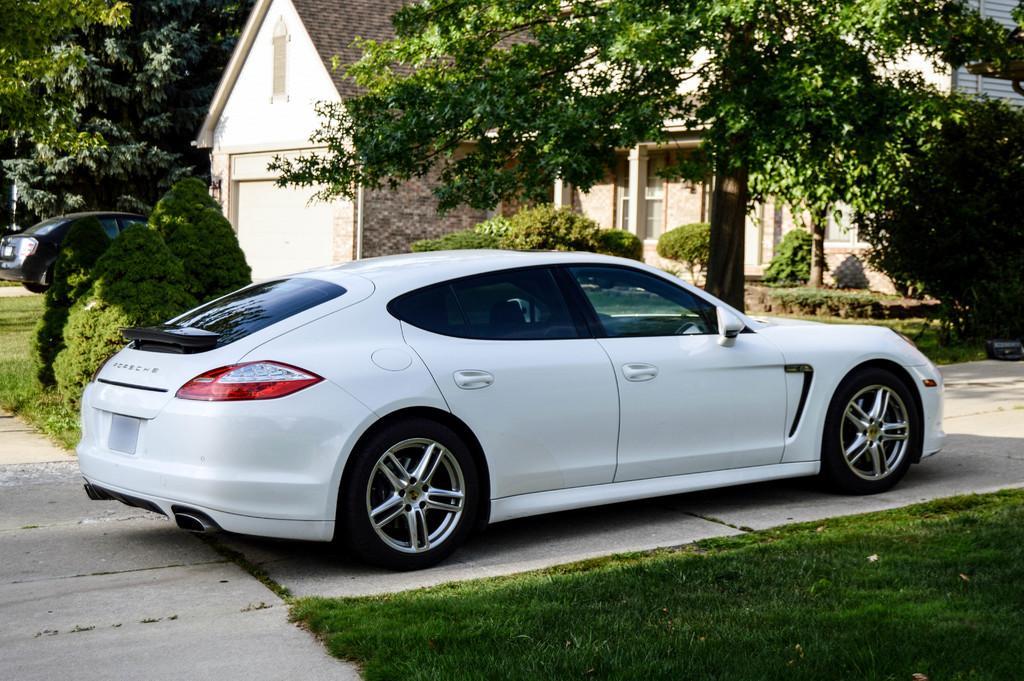How would you summarize this image in a sentence or two? In the picture we can see a car which is parked on the path, the car is white in color and besides the car we can see grass surfaces with some plants, houses with shutters, pillars and doors to it and near to the house we can see some trees. 